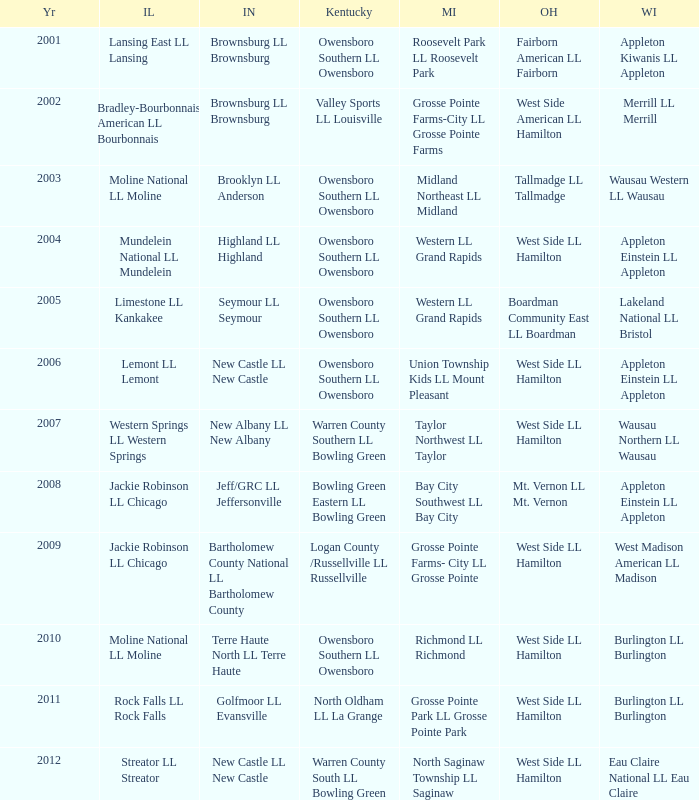What was the little league team from Michigan when the little league team from Indiana was Terre Haute North LL Terre Haute?  Richmond LL Richmond. 